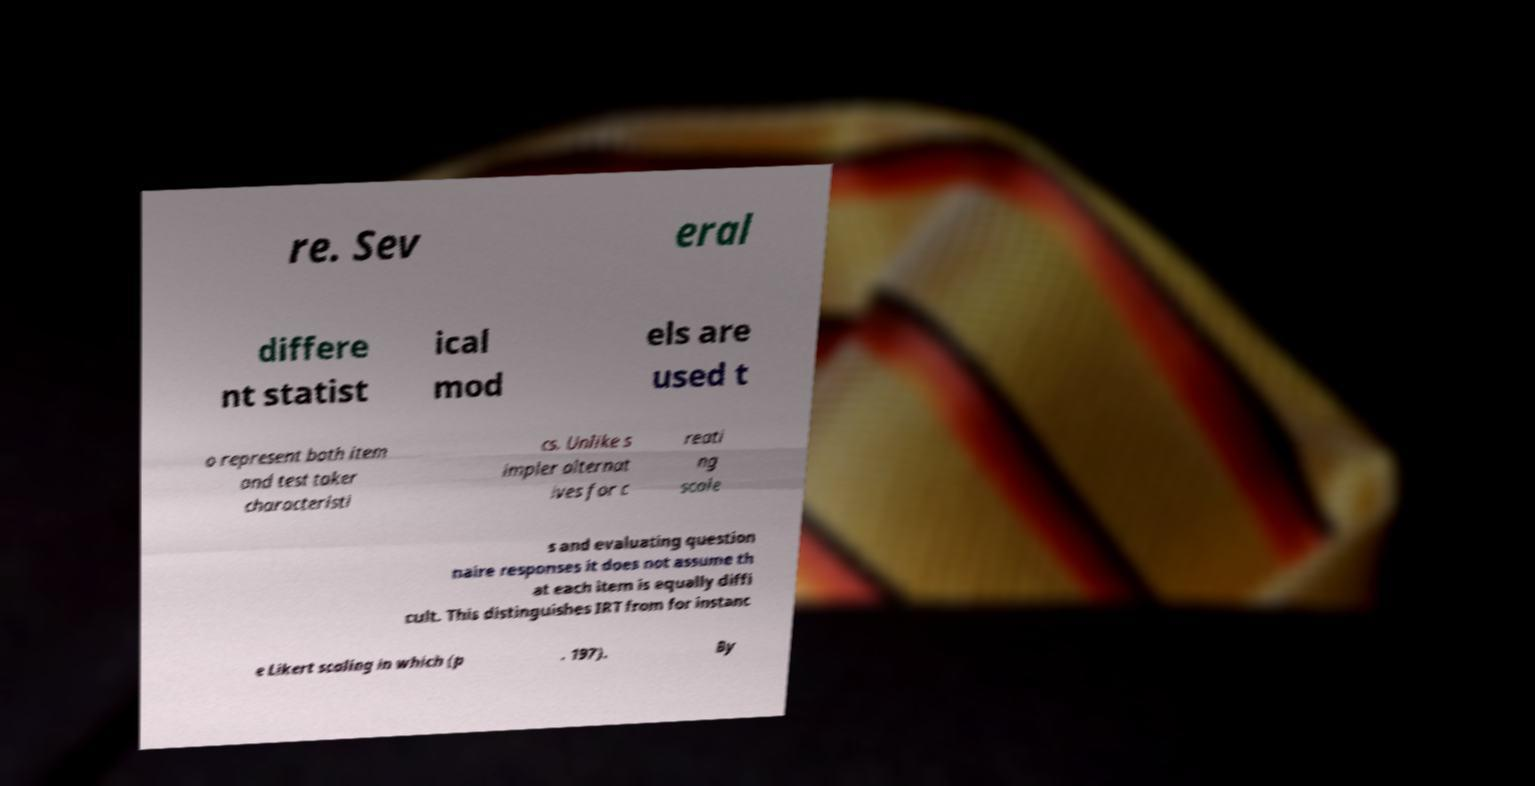I need the written content from this picture converted into text. Can you do that? re. Sev eral differe nt statist ical mod els are used t o represent both item and test taker characteristi cs. Unlike s impler alternat ives for c reati ng scale s and evaluating question naire responses it does not assume th at each item is equally diffi cult. This distinguishes IRT from for instanc e Likert scaling in which (p . 197). By 